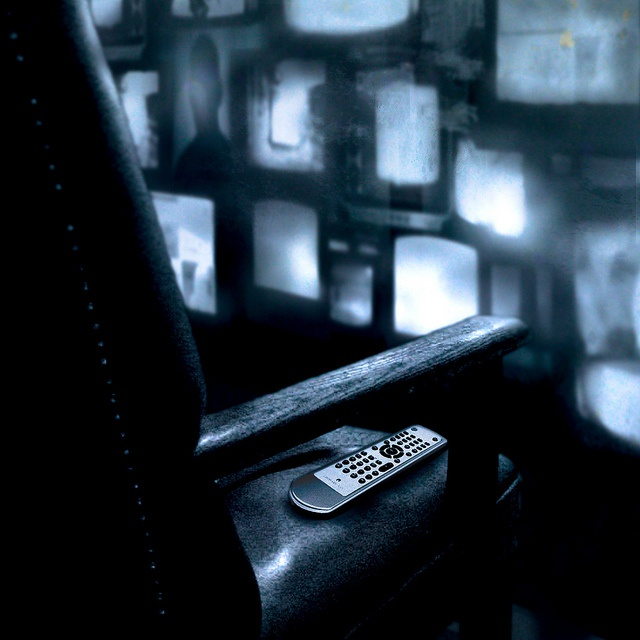Describe the objects in this image and their specific colors. I can see chair in black, blue, darkblue, and gray tones, tv in black, gray, blue, and darkblue tones, tv in black, navy, gray, and lightblue tones, tv in black, navy, darkblue, blue, and lightblue tones, and tv in black, white, blue, and gray tones in this image. 